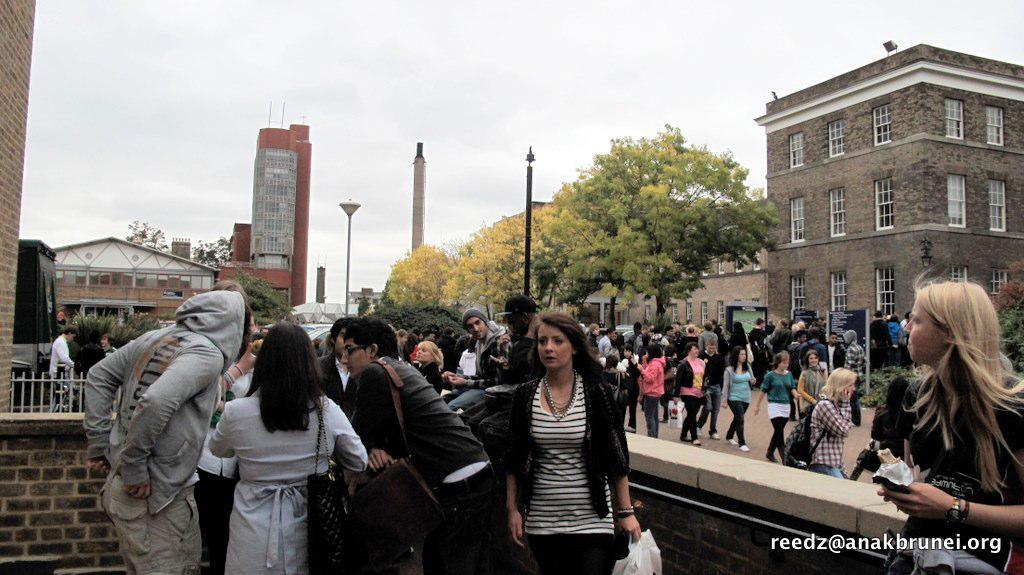What is happening on the road in the image? There are many people standing and walking on the road. What can be seen on the left side of the image? There are buildings to the left. What is visible in the background of the image? In the background, there are trees and poles, as well as buildings. What type of note is being played by the drum in the image? There is no drum or note present in the image. How does the motion of the people on the road affect the buildings in the background? The motion of the people on the road does not affect the buildings in the background; they are separate elements in the image. 